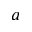<formula> <loc_0><loc_0><loc_500><loc_500>a</formula> 